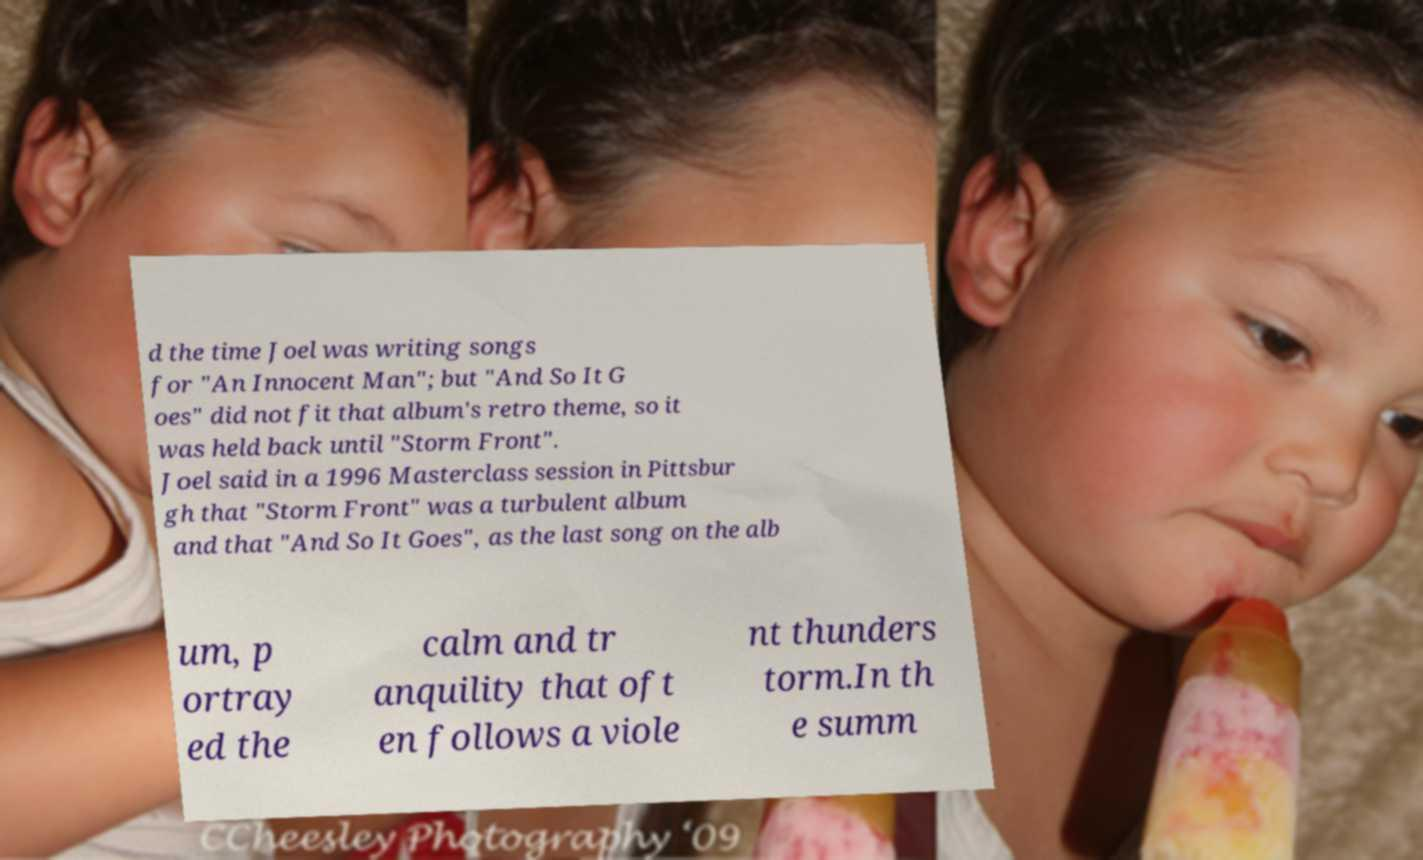Can you accurately transcribe the text from the provided image for me? d the time Joel was writing songs for "An Innocent Man"; but "And So It G oes" did not fit that album's retro theme, so it was held back until "Storm Front". Joel said in a 1996 Masterclass session in Pittsbur gh that "Storm Front" was a turbulent album and that "And So It Goes", as the last song on the alb um, p ortray ed the calm and tr anquility that oft en follows a viole nt thunders torm.In th e summ 